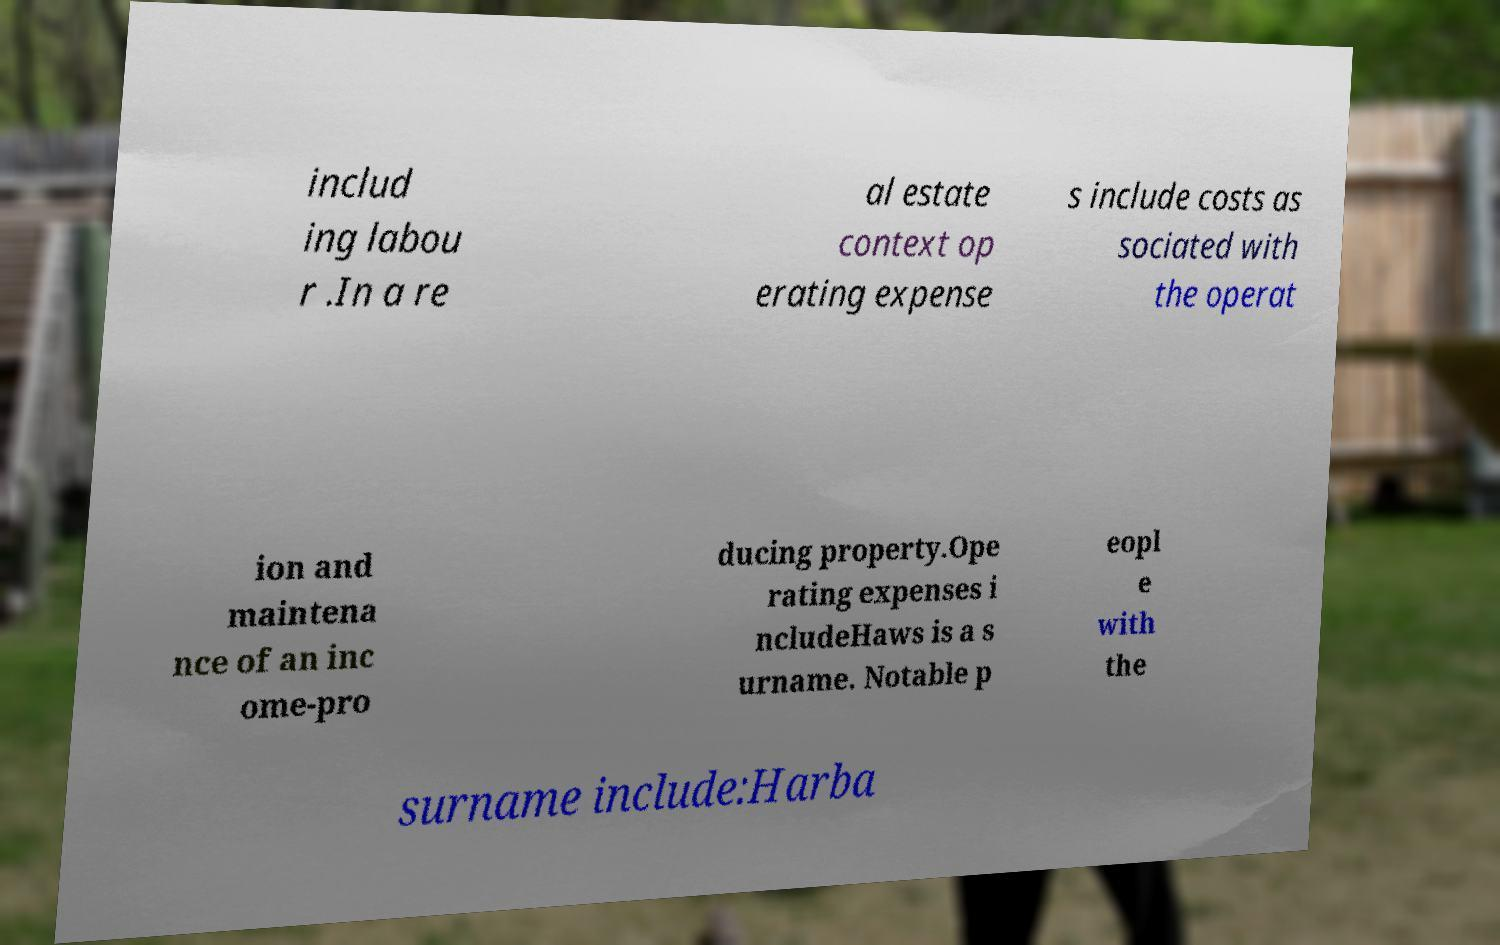Please read and relay the text visible in this image. What does it say? includ ing labou r .In a re al estate context op erating expense s include costs as sociated with the operat ion and maintena nce of an inc ome-pro ducing property.Ope rating expenses i ncludeHaws is a s urname. Notable p eopl e with the surname include:Harba 